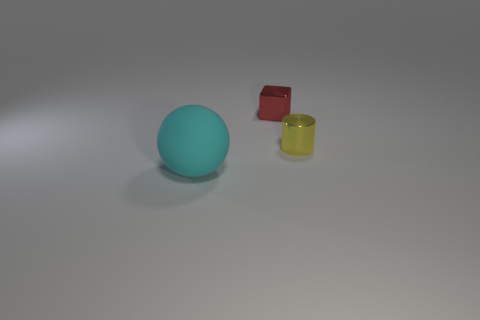What colors are present in the objects displayed? The objects consist of three distinct colors: teal for the sphere, red for the cube, and yellow for the cylinder. 